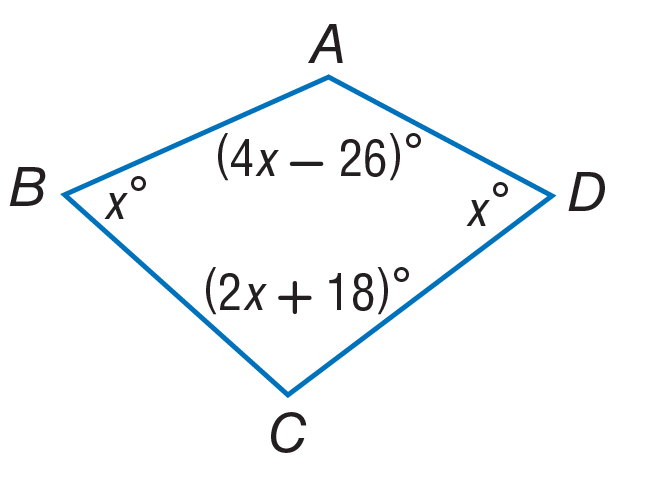Answer the mathemtical geometry problem and directly provide the correct option letter.
Question: Find the measure of \angle B.
Choices: A: 46 B: 92 C: 110 D: 156 A 